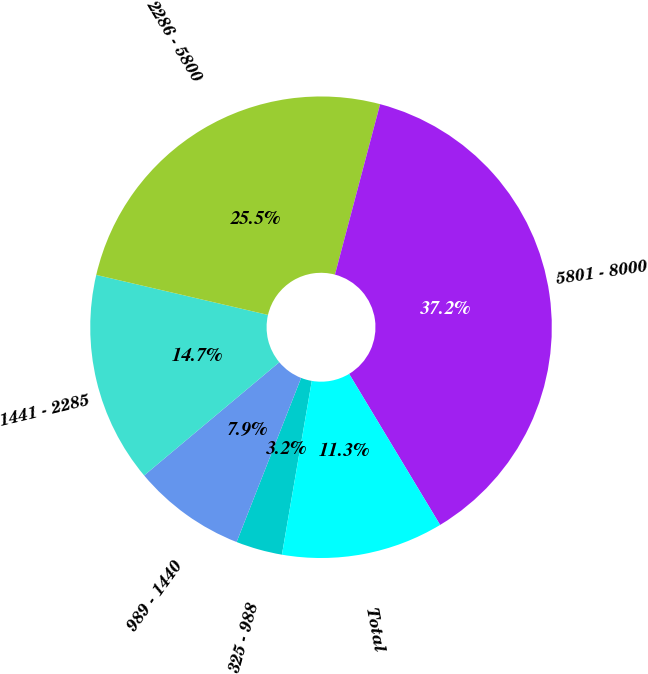Convert chart. <chart><loc_0><loc_0><loc_500><loc_500><pie_chart><fcel>325 - 988<fcel>989 - 1440<fcel>1441 - 2285<fcel>2286 - 5800<fcel>5801 - 8000<fcel>Total<nl><fcel>3.25%<fcel>7.94%<fcel>14.74%<fcel>25.48%<fcel>37.25%<fcel>11.34%<nl></chart> 